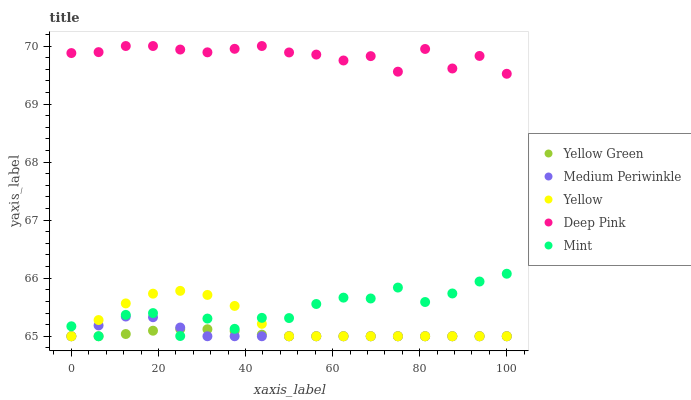Does Yellow Green have the minimum area under the curve?
Answer yes or no. Yes. Does Deep Pink have the maximum area under the curve?
Answer yes or no. Yes. Does Medium Periwinkle have the minimum area under the curve?
Answer yes or no. No. Does Medium Periwinkle have the maximum area under the curve?
Answer yes or no. No. Is Yellow Green the smoothest?
Answer yes or no. Yes. Is Mint the roughest?
Answer yes or no. Yes. Is Deep Pink the smoothest?
Answer yes or no. No. Is Deep Pink the roughest?
Answer yes or no. No. Does Mint have the lowest value?
Answer yes or no. Yes. Does Deep Pink have the lowest value?
Answer yes or no. No. Does Deep Pink have the highest value?
Answer yes or no. Yes. Does Medium Periwinkle have the highest value?
Answer yes or no. No. Is Medium Periwinkle less than Deep Pink?
Answer yes or no. Yes. Is Deep Pink greater than Medium Periwinkle?
Answer yes or no. Yes. Does Medium Periwinkle intersect Yellow?
Answer yes or no. Yes. Is Medium Periwinkle less than Yellow?
Answer yes or no. No. Is Medium Periwinkle greater than Yellow?
Answer yes or no. No. Does Medium Periwinkle intersect Deep Pink?
Answer yes or no. No. 